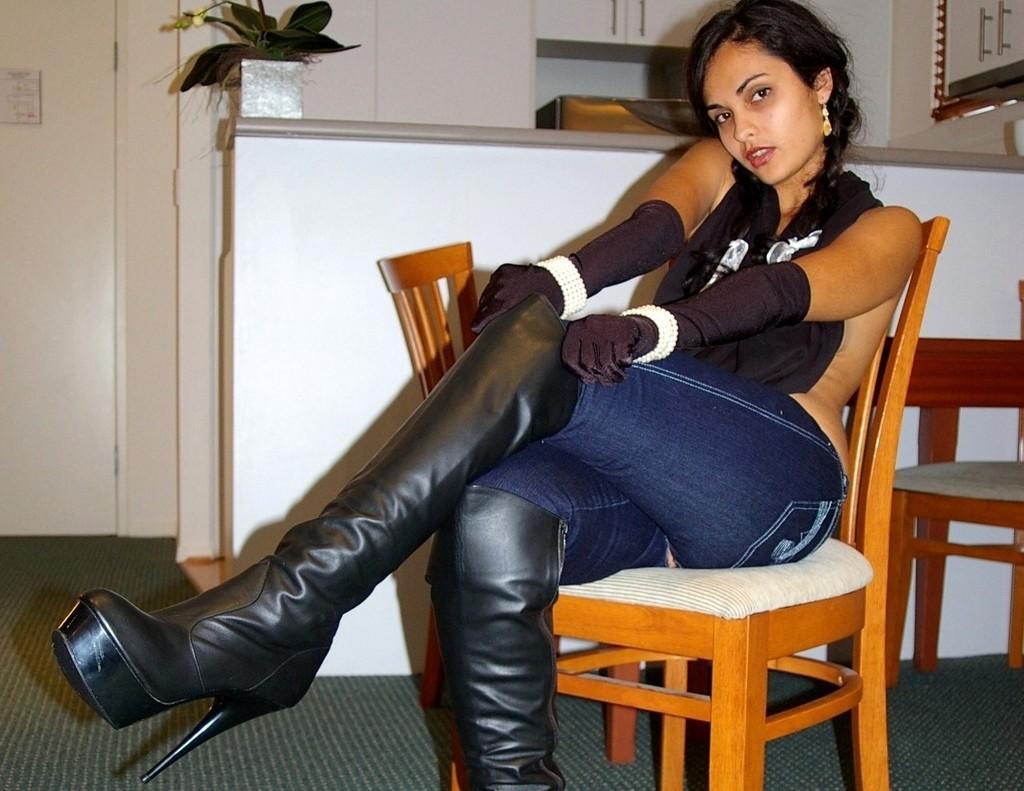Please provide a concise description of this image. In this image i can see a woman sit on the chair and her mouth is open ,back side of her there is a table ,on the table there is a flower pot and there are some leaves on the flower pot and left side i can see a door. On the right side there is another table kept on the floor 